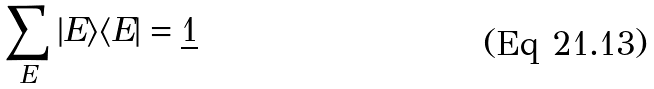<formula> <loc_0><loc_0><loc_500><loc_500>\sum _ { E } | E \rangle \langle E | = \underline { 1 }</formula> 